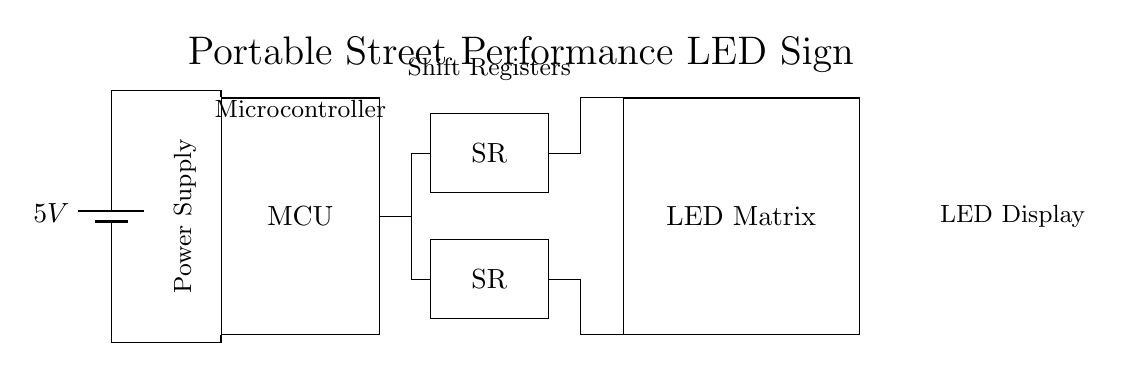What is the voltage in this circuit? The voltage is indicated as 5V from the battery symbol placed at the top left corner of the diagram.
Answer: 5V What components are connected to the microcontroller? The microcontroller is connected to two shift registers, as indicated by the lines leading from the MCU to SR1 and SR2.
Answer: Two shift registers What is the purpose of the shift registers in this circuit? Shift registers serve to expand the data output from the microcontroller, allowing the control of the LED matrix by sending serial data instructions to the two shift registers connected to it.
Answer: Data expansion How many shift registers are there in this circuit? The circuit diagram shows two shift registers labeled SR, positioned one above the other on the right side of the microcontroller.
Answer: Two What is the main output device in this circuit? The main output device is the LED matrix which is drawn to the right of the shift registers and is responsible for displaying the visual output.
Answer: LED matrix What type of circuit is represented here? This is a digital circuit, as indicated by the presence of a microcontroller and digital components such as shift registers and an LED matrix.
Answer: Digital circuit Why are the power connections made in this circuit? Power connections are made to provide the required operating voltage (5V) to the microcontroller and other components, ensuring that they function correctly.
Answer: To provide operating voltage 